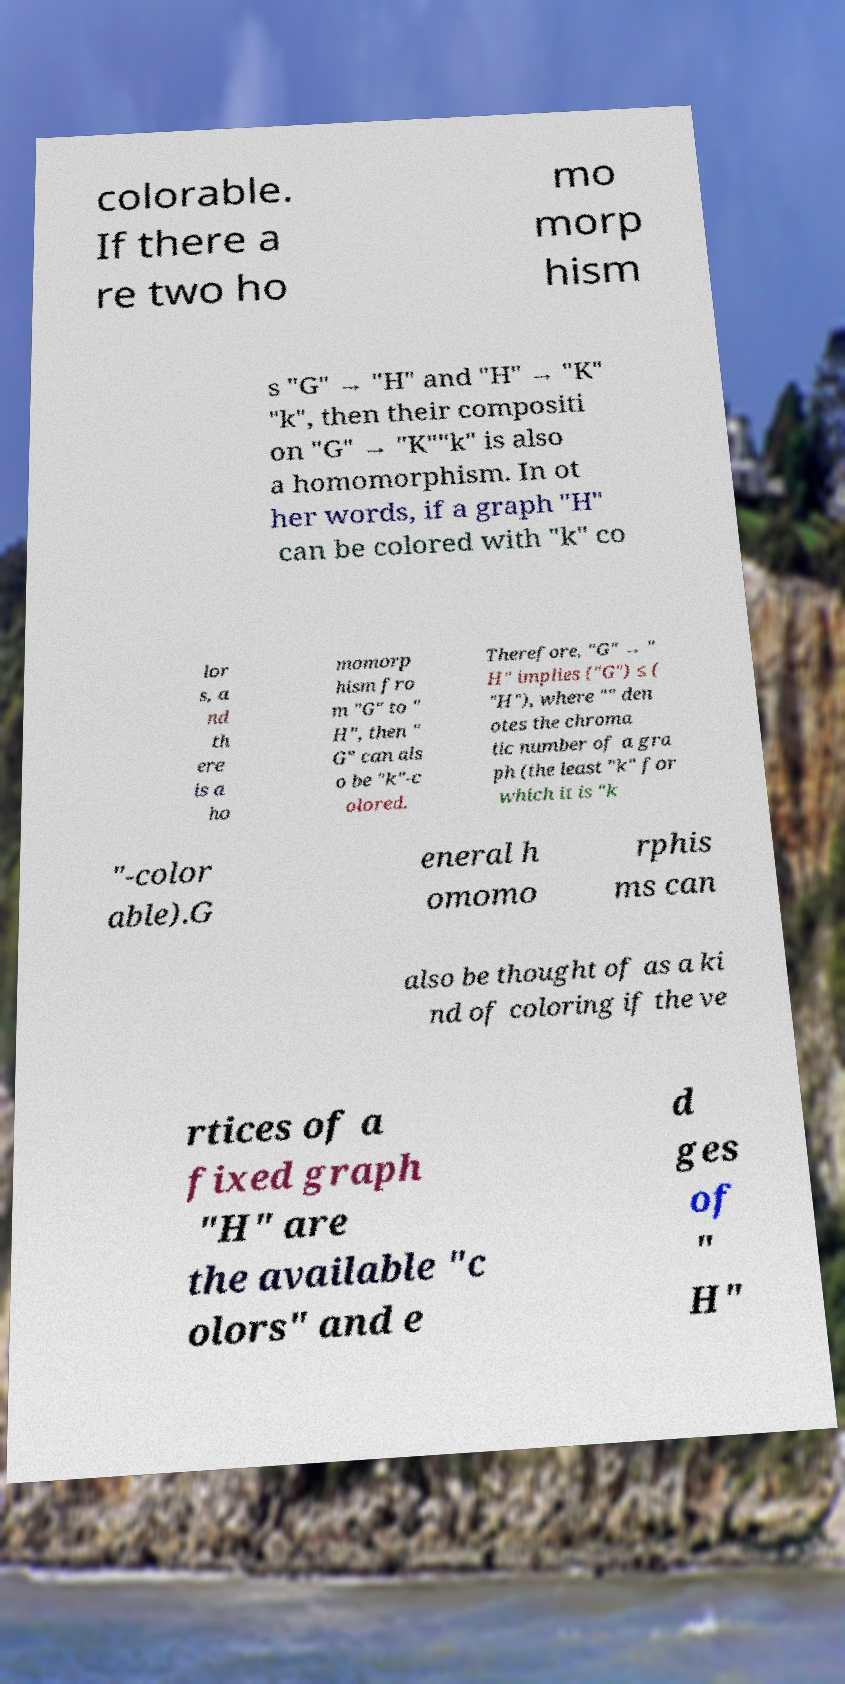Can you accurately transcribe the text from the provided image for me? colorable. If there a re two ho mo morp hism s "G" → "H" and "H" → "K" "k", then their compositi on "G" → "K""k" is also a homomorphism. In ot her words, if a graph "H" can be colored with "k" co lor s, a nd th ere is a ho momorp hism fro m "G" to " H", then " G" can als o be "k"-c olored. Therefore, "G" → " H" implies ("G") ≤ ( "H"), where "" den otes the chroma tic number of a gra ph (the least "k" for which it is "k "-color able).G eneral h omomo rphis ms can also be thought of as a ki nd of coloring if the ve rtices of a fixed graph "H" are the available "c olors" and e d ges of " H" 